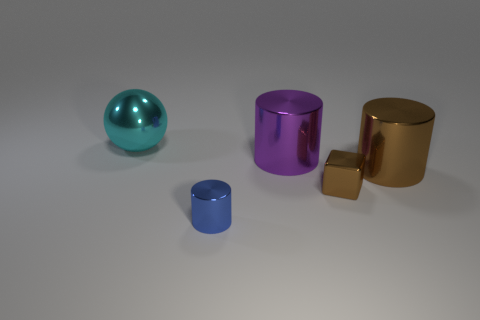Add 2 big things. How many objects exist? 7 Subtract 0 brown balls. How many objects are left? 5 Subtract all cylinders. How many objects are left? 2 Subtract all purple cylinders. Subtract all shiny blocks. How many objects are left? 3 Add 2 small brown shiny cubes. How many small brown shiny cubes are left? 3 Add 3 gray metallic cylinders. How many gray metallic cylinders exist? 3 